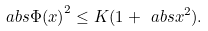Convert formula to latex. <formula><loc_0><loc_0><loc_500><loc_500>\ a b s { \Phi ( x ) } ^ { 2 } \leq K ( 1 + \ a b s { x } ^ { 2 } ) .</formula> 